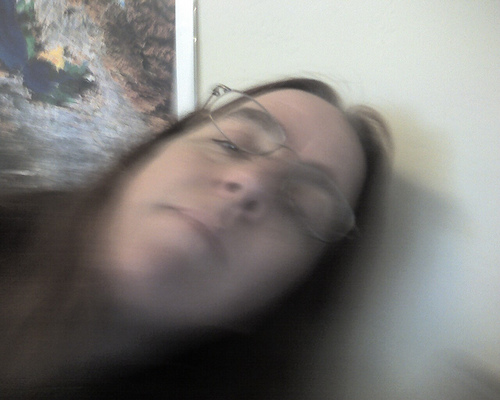<image>
Is there a person on the wall? No. The person is not positioned on the wall. They may be near each other, but the person is not supported by or resting on top of the wall. 